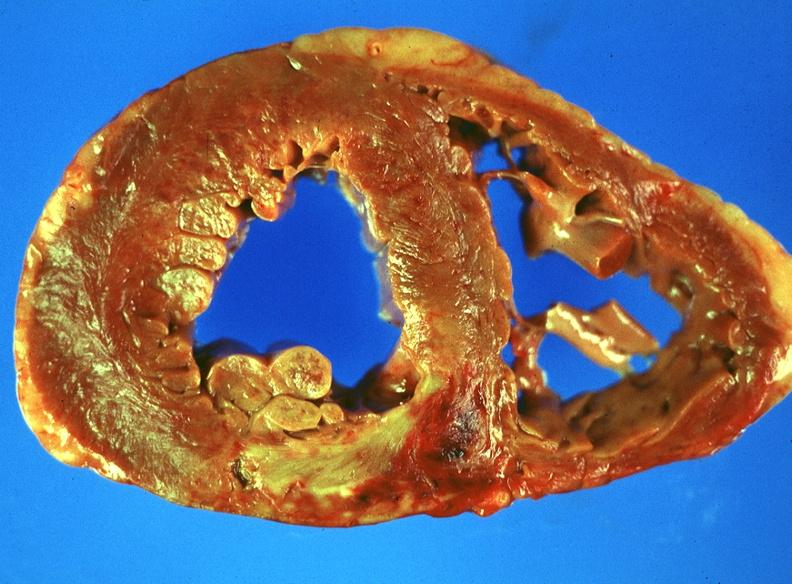does this image show acute myocardial infarction?
Answer the question using a single word or phrase. Yes 